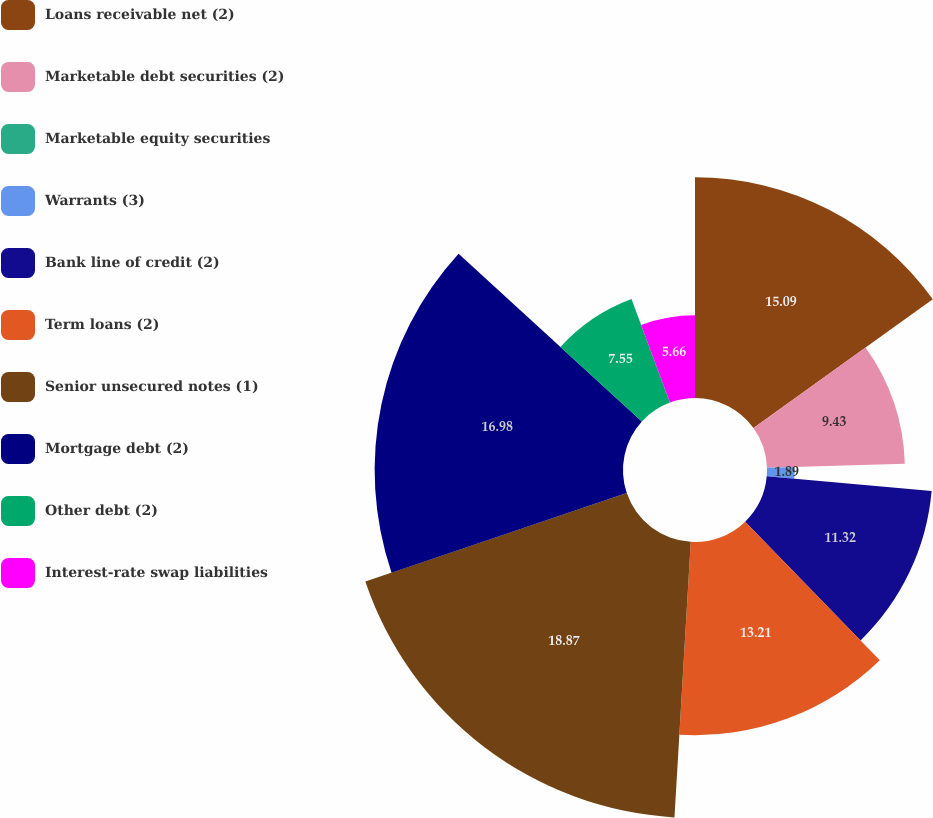<chart> <loc_0><loc_0><loc_500><loc_500><pie_chart><fcel>Loans receivable net (2)<fcel>Marketable debt securities (2)<fcel>Marketable equity securities<fcel>Warrants (3)<fcel>Bank line of credit (2)<fcel>Term loans (2)<fcel>Senior unsecured notes (1)<fcel>Mortgage debt (2)<fcel>Other debt (2)<fcel>Interest-rate swap liabilities<nl><fcel>15.09%<fcel>9.43%<fcel>0.0%<fcel>1.89%<fcel>11.32%<fcel>13.21%<fcel>18.87%<fcel>16.98%<fcel>7.55%<fcel>5.66%<nl></chart> 